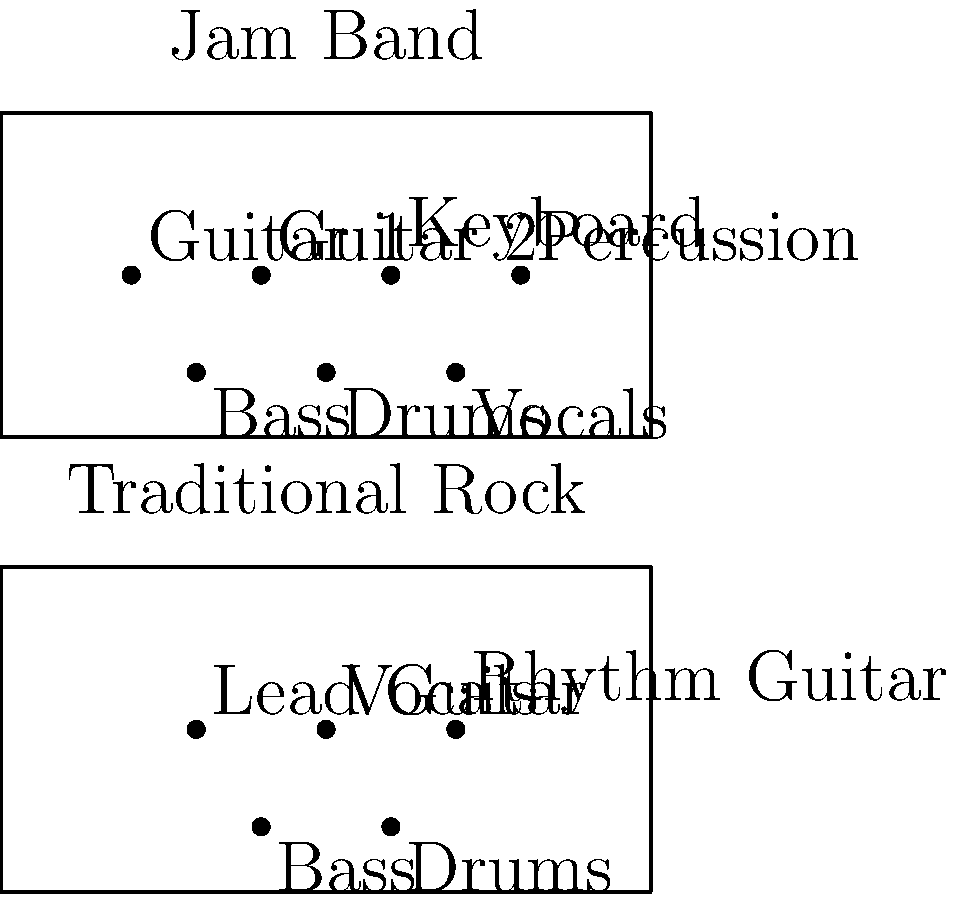Based on the diagram, which key difference in stage setup between a jam band and a traditional rock band might contribute to extended improvisational sections in jam band performances? To answer this question, let's analyze the stage setups step-by-step:

1. Traditional Rock Setup:
   - Lead Guitar, Vocals, and Rhythm Guitar are positioned in the front
   - Bass and Drums are positioned in the back
   - Total of 5 distinct positions

2. Jam Band Setup:
   - More spread out configuration
   - Two Guitars, Keyboard, and Percussion in the front
   - Bass, Drums, and Vocals in the back
   - Total of 7 distinct positions

3. Key Differences:
   a) More instruments: Jam bands typically have additional instruments (e.g., keyboard, percussion) compared to traditional rock bands.
   b) Multiple guitarists: Jam bands often feature two guitarists, allowing for more intricate interplay and extended solos.
   c) Percussion separate from drums: This allows for more complex rhythmic patterns and improvisational opportunities.
   d) Keyboard presence: Adds harmonic complexity and another soloing instrument.

4. Impact on Improvisation:
   - The additional instruments and their arrangement allow for more musical interactions.
   - Multiple lead instruments (two guitars, keyboard) can trade solos or play off each other.
   - The expanded rhythm section (drums, percussion, bass) provides a more robust foundation for extended jams.

5. Conclusion:
   The key difference contributing to extended improvisational sections is the presence of additional instruments, particularly the second guitar and keyboard, which allows for more complex musical interplay and extended soloing opportunities.
Answer: Additional instruments (second guitar and keyboard) 